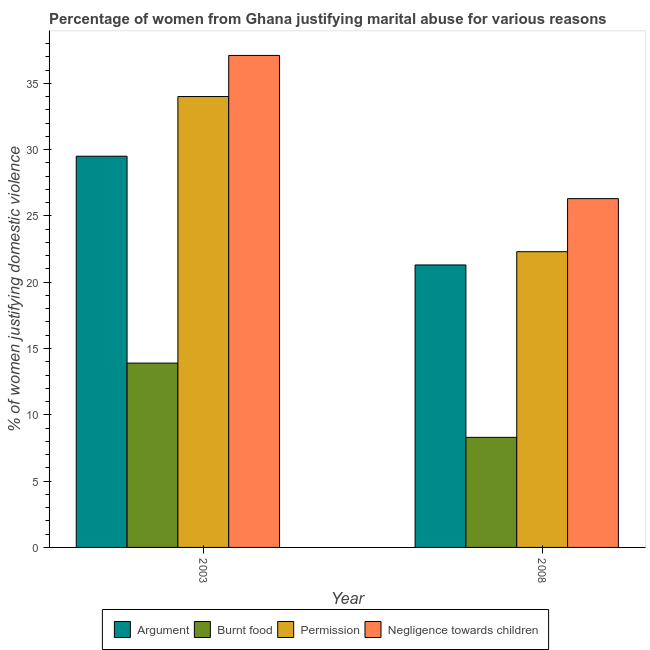How many different coloured bars are there?
Ensure brevity in your answer.  4. How many bars are there on the 2nd tick from the left?
Your answer should be very brief. 4. What is the percentage of women justifying abuse for showing negligence towards children in 2008?
Your response must be concise. 26.3. Across all years, what is the maximum percentage of women justifying abuse for burning food?
Make the answer very short. 13.9. Across all years, what is the minimum percentage of women justifying abuse for showing negligence towards children?
Keep it short and to the point. 26.3. What is the total percentage of women justifying abuse in the case of an argument in the graph?
Make the answer very short. 50.8. What is the difference between the percentage of women justifying abuse for burning food in 2003 and that in 2008?
Provide a succinct answer. 5.6. What is the difference between the percentage of women justifying abuse in the case of an argument in 2008 and the percentage of women justifying abuse for burning food in 2003?
Your answer should be very brief. -8.2. What is the average percentage of women justifying abuse for burning food per year?
Provide a succinct answer. 11.1. In the year 2008, what is the difference between the percentage of women justifying abuse for going without permission and percentage of women justifying abuse for showing negligence towards children?
Provide a succinct answer. 0. What is the ratio of the percentage of women justifying abuse for showing negligence towards children in 2003 to that in 2008?
Provide a short and direct response. 1.41. What does the 1st bar from the left in 2008 represents?
Offer a terse response. Argument. What does the 3rd bar from the right in 2003 represents?
Ensure brevity in your answer.  Burnt food. Is it the case that in every year, the sum of the percentage of women justifying abuse in the case of an argument and percentage of women justifying abuse for burning food is greater than the percentage of women justifying abuse for going without permission?
Keep it short and to the point. Yes. Are all the bars in the graph horizontal?
Offer a very short reply. No. What is the difference between two consecutive major ticks on the Y-axis?
Keep it short and to the point. 5. Does the graph contain any zero values?
Your response must be concise. No. How many legend labels are there?
Your answer should be compact. 4. What is the title of the graph?
Your answer should be very brief. Percentage of women from Ghana justifying marital abuse for various reasons. What is the label or title of the X-axis?
Ensure brevity in your answer.  Year. What is the label or title of the Y-axis?
Provide a short and direct response. % of women justifying domestic violence. What is the % of women justifying domestic violence in Argument in 2003?
Your response must be concise. 29.5. What is the % of women justifying domestic violence in Burnt food in 2003?
Keep it short and to the point. 13.9. What is the % of women justifying domestic violence of Permission in 2003?
Offer a terse response. 34. What is the % of women justifying domestic violence in Negligence towards children in 2003?
Offer a terse response. 37.1. What is the % of women justifying domestic violence of Argument in 2008?
Ensure brevity in your answer.  21.3. What is the % of women justifying domestic violence of Burnt food in 2008?
Make the answer very short. 8.3. What is the % of women justifying domestic violence of Permission in 2008?
Your answer should be compact. 22.3. What is the % of women justifying domestic violence in Negligence towards children in 2008?
Keep it short and to the point. 26.3. Across all years, what is the maximum % of women justifying domestic violence in Argument?
Offer a very short reply. 29.5. Across all years, what is the maximum % of women justifying domestic violence in Burnt food?
Provide a short and direct response. 13.9. Across all years, what is the maximum % of women justifying domestic violence in Negligence towards children?
Your answer should be compact. 37.1. Across all years, what is the minimum % of women justifying domestic violence in Argument?
Ensure brevity in your answer.  21.3. Across all years, what is the minimum % of women justifying domestic violence of Permission?
Your answer should be very brief. 22.3. Across all years, what is the minimum % of women justifying domestic violence in Negligence towards children?
Provide a succinct answer. 26.3. What is the total % of women justifying domestic violence of Argument in the graph?
Offer a terse response. 50.8. What is the total % of women justifying domestic violence of Permission in the graph?
Ensure brevity in your answer.  56.3. What is the total % of women justifying domestic violence of Negligence towards children in the graph?
Your answer should be very brief. 63.4. What is the difference between the % of women justifying domestic violence of Permission in 2003 and that in 2008?
Offer a terse response. 11.7. What is the difference between the % of women justifying domestic violence in Negligence towards children in 2003 and that in 2008?
Make the answer very short. 10.8. What is the difference between the % of women justifying domestic violence of Argument in 2003 and the % of women justifying domestic violence of Burnt food in 2008?
Your answer should be compact. 21.2. What is the difference between the % of women justifying domestic violence in Argument in 2003 and the % of women justifying domestic violence in Permission in 2008?
Your answer should be very brief. 7.2. What is the difference between the % of women justifying domestic violence of Argument in 2003 and the % of women justifying domestic violence of Negligence towards children in 2008?
Provide a succinct answer. 3.2. What is the difference between the % of women justifying domestic violence of Burnt food in 2003 and the % of women justifying domestic violence of Permission in 2008?
Give a very brief answer. -8.4. What is the difference between the % of women justifying domestic violence in Burnt food in 2003 and the % of women justifying domestic violence in Negligence towards children in 2008?
Provide a succinct answer. -12.4. What is the average % of women justifying domestic violence in Argument per year?
Ensure brevity in your answer.  25.4. What is the average % of women justifying domestic violence in Burnt food per year?
Ensure brevity in your answer.  11.1. What is the average % of women justifying domestic violence of Permission per year?
Make the answer very short. 28.15. What is the average % of women justifying domestic violence of Negligence towards children per year?
Provide a short and direct response. 31.7. In the year 2003, what is the difference between the % of women justifying domestic violence of Argument and % of women justifying domestic violence of Permission?
Ensure brevity in your answer.  -4.5. In the year 2003, what is the difference between the % of women justifying domestic violence in Argument and % of women justifying domestic violence in Negligence towards children?
Your answer should be very brief. -7.6. In the year 2003, what is the difference between the % of women justifying domestic violence of Burnt food and % of women justifying domestic violence of Permission?
Your response must be concise. -20.1. In the year 2003, what is the difference between the % of women justifying domestic violence in Burnt food and % of women justifying domestic violence in Negligence towards children?
Provide a succinct answer. -23.2. In the year 2008, what is the difference between the % of women justifying domestic violence of Argument and % of women justifying domestic violence of Burnt food?
Provide a succinct answer. 13. In the year 2008, what is the difference between the % of women justifying domestic violence of Argument and % of women justifying domestic violence of Permission?
Provide a short and direct response. -1. What is the ratio of the % of women justifying domestic violence of Argument in 2003 to that in 2008?
Your answer should be compact. 1.39. What is the ratio of the % of women justifying domestic violence of Burnt food in 2003 to that in 2008?
Keep it short and to the point. 1.67. What is the ratio of the % of women justifying domestic violence of Permission in 2003 to that in 2008?
Keep it short and to the point. 1.52. What is the ratio of the % of women justifying domestic violence of Negligence towards children in 2003 to that in 2008?
Your answer should be very brief. 1.41. What is the difference between the highest and the second highest % of women justifying domestic violence of Argument?
Ensure brevity in your answer.  8.2. What is the difference between the highest and the second highest % of women justifying domestic violence of Burnt food?
Give a very brief answer. 5.6. What is the difference between the highest and the second highest % of women justifying domestic violence in Permission?
Give a very brief answer. 11.7. What is the difference between the highest and the lowest % of women justifying domestic violence in Argument?
Give a very brief answer. 8.2. What is the difference between the highest and the lowest % of women justifying domestic violence in Burnt food?
Your response must be concise. 5.6. What is the difference between the highest and the lowest % of women justifying domestic violence in Permission?
Make the answer very short. 11.7. What is the difference between the highest and the lowest % of women justifying domestic violence of Negligence towards children?
Provide a succinct answer. 10.8. 